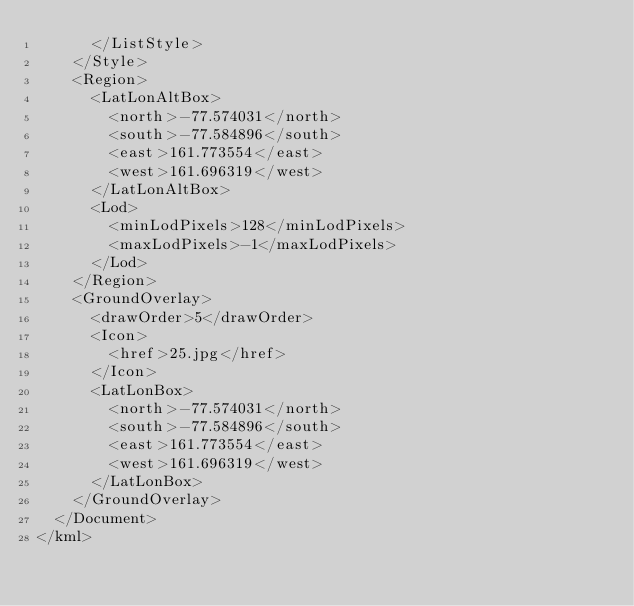Convert code to text. <code><loc_0><loc_0><loc_500><loc_500><_XML_>			</ListStyle>
		</Style>
		<Region>
			<LatLonAltBox>
				<north>-77.574031</north>
				<south>-77.584896</south>
				<east>161.773554</east>
				<west>161.696319</west>
			</LatLonAltBox>
			<Lod>
				<minLodPixels>128</minLodPixels>
				<maxLodPixels>-1</maxLodPixels>
			</Lod>
		</Region>
		<GroundOverlay>
			<drawOrder>5</drawOrder>
			<Icon>
				<href>25.jpg</href>
			</Icon>
			<LatLonBox>
				<north>-77.574031</north>
				<south>-77.584896</south>
				<east>161.773554</east>
				<west>161.696319</west>
			</LatLonBox>
		</GroundOverlay>
	</Document>
</kml>
</code> 